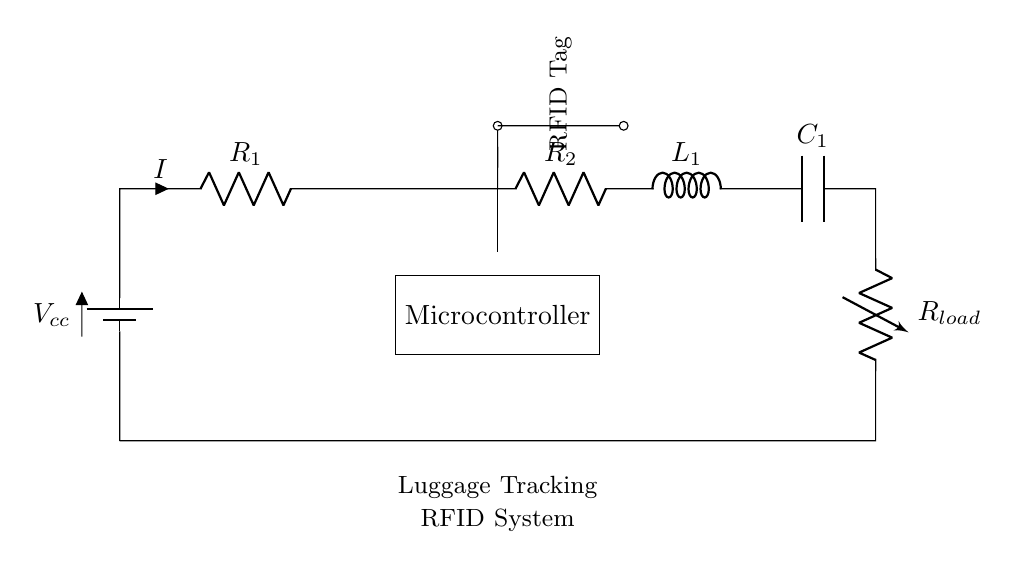What is the main power source in this circuit? The main power source is indicated as \( V_{cc} \) in the circuit diagram, which supplies voltage to the entire system.
Answer: \( V_{cc} \) What types of components are connected in series in this circuit? The components that are connected in series include a battery, resistors, an antenna, an inductor, a capacitor, and a load resistor. Since they are drawn in a single path, they share the same current.
Answer: Resistor, antenna, inductor, capacitor, load resistor What is the purpose of the microcontroller in this circuit? The microcontroller is designed to manage the operation of the RFID system, processing the signals from the RFID tag. Its placement allows it to connect directly to the antenna.
Answer: Manage signals How many resistors are present in the circuit? There are two resistors in the circuit labeled as \( R_1 \) and \( R_2 \). They are part of the series connection providing current limiting and voltage division as needed.
Answer: Two What is the function of the RFID tag shown in the diagram? The RFID tag functions as an identifier that communicates with the system wirelessly when activated by the antenna. This interaction is essential for tracking luggage.
Answer: Identification What happens to the current throughout the circuit? The current remains the same throughout all components in a series circuit, which is a defining feature of series configurations. This means the current flowing through \( R_1 \), \( R_2 \), and other components is equal.
Answer: Remains same What is the configuration of this circuit type? The configuration is a series circuit, where all components are connected end-to-end, allowing current to flow through each component in a single path.
Answer: Series 